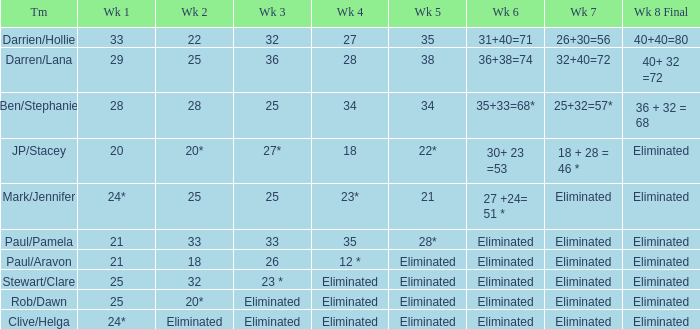Name the week 3 for team of mark/jennifer 25.0. 